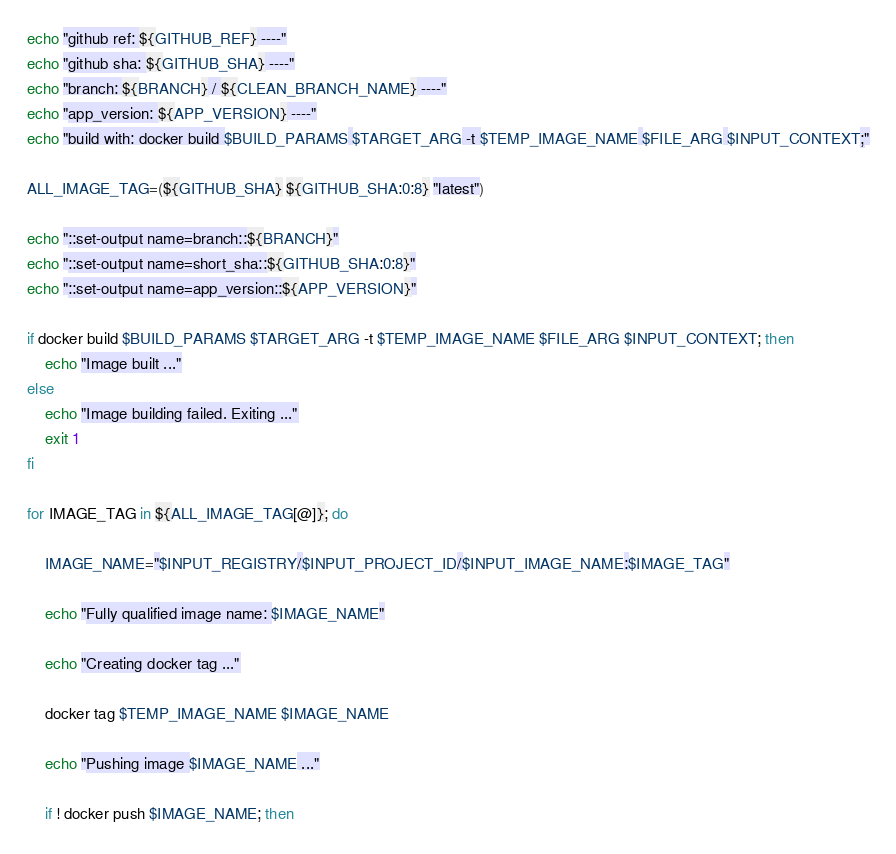Convert code to text. <code><loc_0><loc_0><loc_500><loc_500><_Bash_>
echo "github ref: ${GITHUB_REF} ----"
echo "github sha: ${GITHUB_SHA} ----"
echo "branch: ${BRANCH} / ${CLEAN_BRANCH_NAME} ----"
echo "app_version: ${APP_VERSION} ----"
echo "build with: docker build $BUILD_PARAMS $TARGET_ARG -t $TEMP_IMAGE_NAME $FILE_ARG $INPUT_CONTEXT;"

ALL_IMAGE_TAG=(${GITHUB_SHA} ${GITHUB_SHA:0:8} "latest")

echo "::set-output name=branch::${BRANCH}"
echo "::set-output name=short_sha::${GITHUB_SHA:0:8}"
echo "::set-output name=app_version::${APP_VERSION}"

if docker build $BUILD_PARAMS $TARGET_ARG -t $TEMP_IMAGE_NAME $FILE_ARG $INPUT_CONTEXT; then
    echo "Image built ..."
else
    echo "Image building failed. Exiting ..."
    exit 1
fi

for IMAGE_TAG in ${ALL_IMAGE_TAG[@]}; do

    IMAGE_NAME="$INPUT_REGISTRY/$INPUT_PROJECT_ID/$INPUT_IMAGE_NAME:$IMAGE_TAG"

    echo "Fully qualified image name: $IMAGE_NAME"

    echo "Creating docker tag ..."

    docker tag $TEMP_IMAGE_NAME $IMAGE_NAME

    echo "Pushing image $IMAGE_NAME ..."

    if ! docker push $IMAGE_NAME; then</code> 